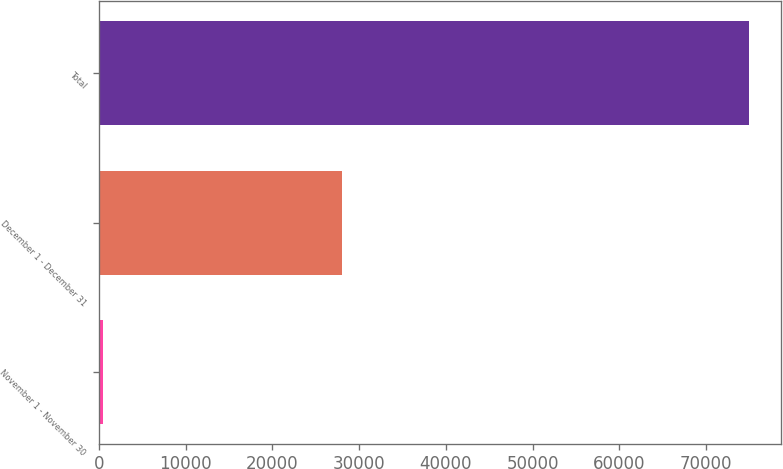Convert chart to OTSL. <chart><loc_0><loc_0><loc_500><loc_500><bar_chart><fcel>November 1 - November 30<fcel>December 1 - December 31<fcel>Total<nl><fcel>484<fcel>28077<fcel>74919<nl></chart> 